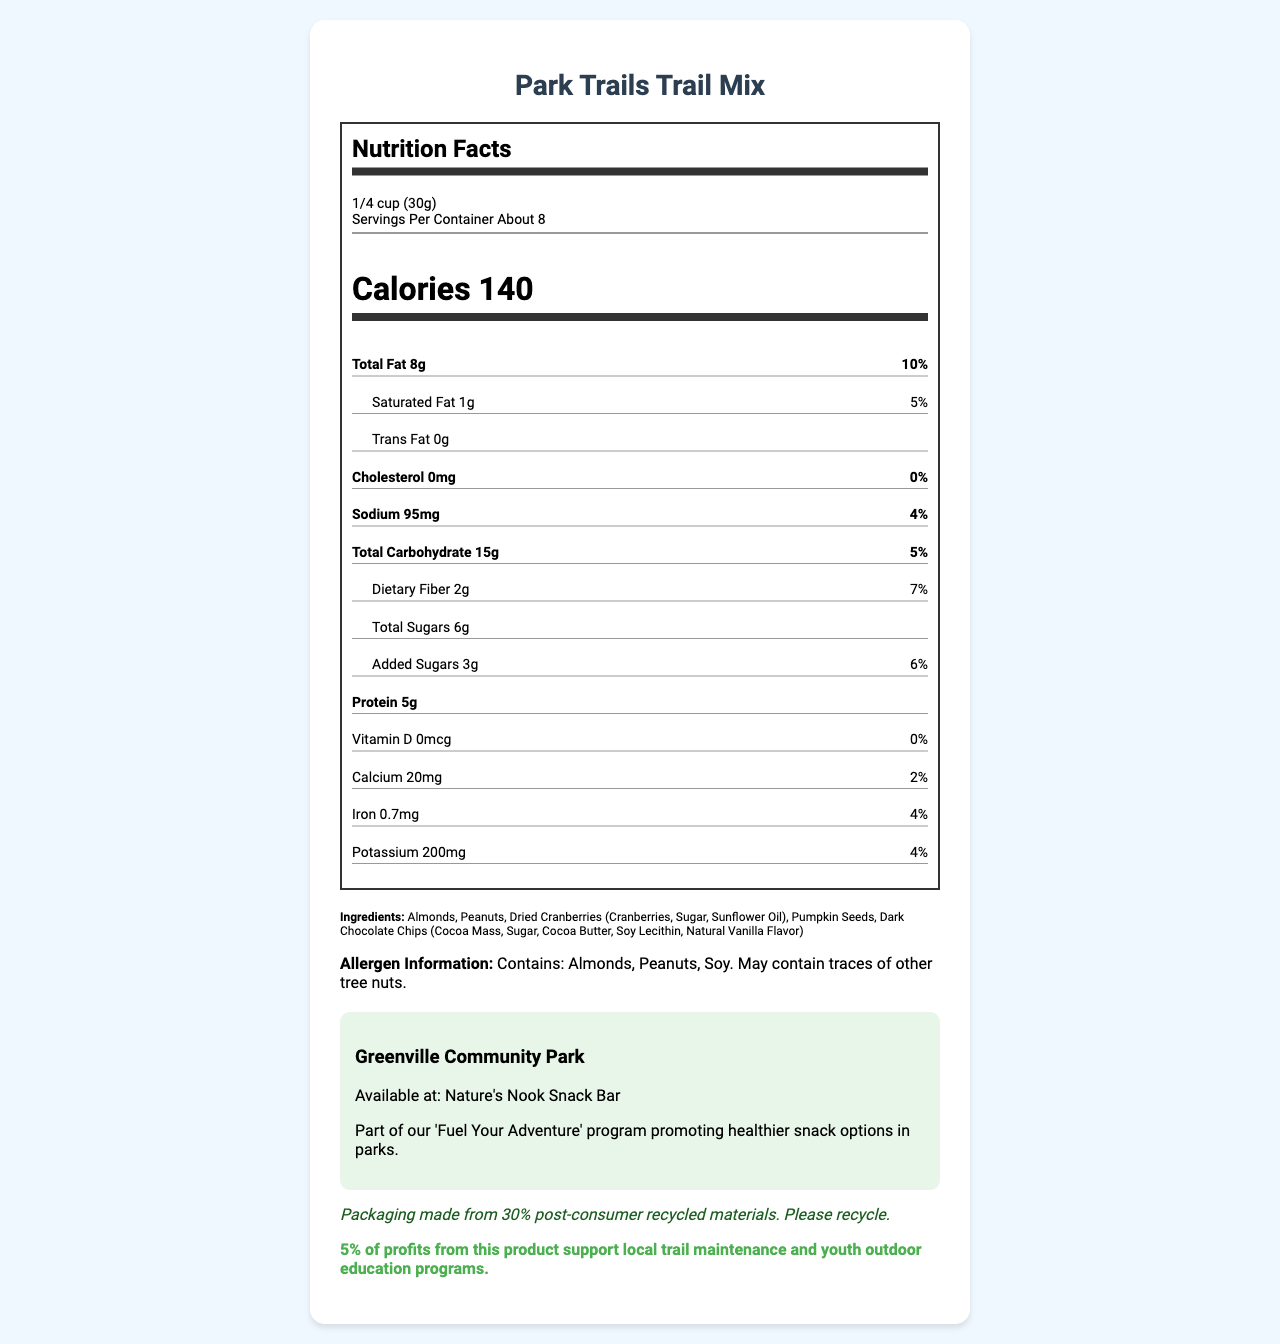what is the serving size for Park Trails Trail Mix? The serving size is indicated at the top of the nutrition facts section as "1/4 cup (30g)".
Answer: 1/4 cup (30g) how many servings are in each container? The number of servings per container is listed under the serving size as "About 8".
Answer: About 8 how many calories are in one serving of Park Trails Trail Mix? The calorie count for one serving is prominently displayed under the serving information as "Calories 140".
Answer: 140 how much sodium is in a serving? The sodium content is listed in the lower section of the nutrition label as "Sodium 95mg".
Answer: 95mg what percentage of the daily value of protein does one serving provide? The document does not list the daily value percentage for protein, just the amount, which is "5g".
Answer: Not specified how much dietary fiber does one serving contain? The dietary fiber content per serving is displayed under total carbohydrate as "Dietary Fiber 2g".
Answer: 2g which of the following ingredients are present in Park Trails Trail Mix? A. Walnuts B. Almonds C. Raisins The listed ingredients include almonds but not walnuts or raisins.
Answer: B how much calcium is in one serving? A. 0mg B. 20mg C. 200mg D. 0.7mg The calcium amount per serving is listed under vitamins and minerals as "Calcium 20mg".
Answer: B does this product contain any trans fat? The document states "Trans Fat 0g".
Answer: No what are the allergens mentioned in the Park Trails Trail Mix? The allergen information indicates that the product contains almonds, peanuts, and soy.
Answer: Almonds, Peanuts, Soy does the document mention if the packaging is recyclable? There is a note under sustainability that states "Packaging made from 30% post-consumer recycled materials. Please recycle."
Answer: Yes summarize the main information provided in the document. This summary captures the main points like the product's nutritional information, ingredients, allergen warnings, sustainability efforts, and community impact.
Answer: The document provides the nutrition facts for Park Trails Trail Mix, including serving size, servings per container, calorie count, and detailed nutrient information. It lists the product's ingredients and allergen information, mentions its availability at Greenville Community Park's Nature's Nook Snack Bar as part of their healthy initiative, highlights the sustainability of its packaging, and notes that 5% of profits support local trail maintenance and youth programs. what is the name of the park where this product is sold? The park information section states that the product is available at Greenville Community Park.
Answer: Greenville Community Park how many grams of added sugars are in one serving? The added sugars amount is listed under total carbohydrate as "Added Sugars 3g".
Answer: 3g is the trail mix part of a specific program? The document mentions that the trail mix is part of the 'Fuel Your Adventure' program promoting healthier snack options in parks.
Answer: Yes how much iron is in one serving? The iron content per serving is listed under vitamins and minerals as "Iron 0.7mg".
Answer: 0.7mg can we determine the manufacturing location of Park Trails Trail Mix based on this document? The document does not provide any information regarding the manufacturing location of the product.
Answer: Cannot be determined 